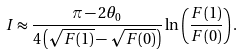<formula> <loc_0><loc_0><loc_500><loc_500>I \approx \frac { \pi - 2 \theta _ { 0 } } { 4 \left ( \sqrt { F ( 1 ) } - \sqrt { F ( 0 ) } \right ) } \ln \left ( \frac { F ( 1 ) } { F ( 0 ) } \right ) .</formula> 